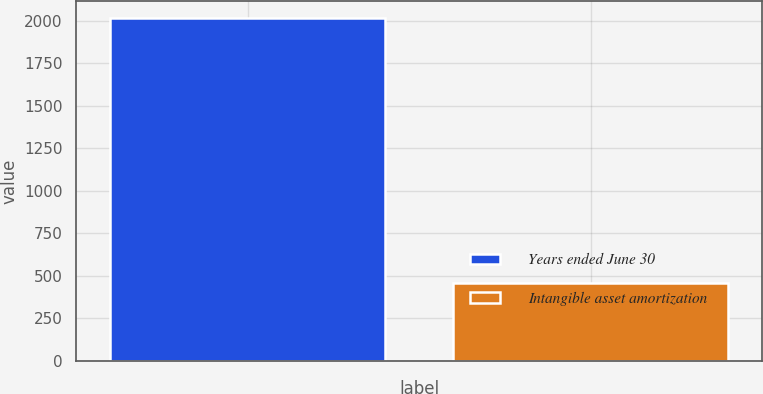Convert chart. <chart><loc_0><loc_0><loc_500><loc_500><bar_chart><fcel>Years ended June 30<fcel>Intangible asset amortization<nl><fcel>2015<fcel>457<nl></chart> 